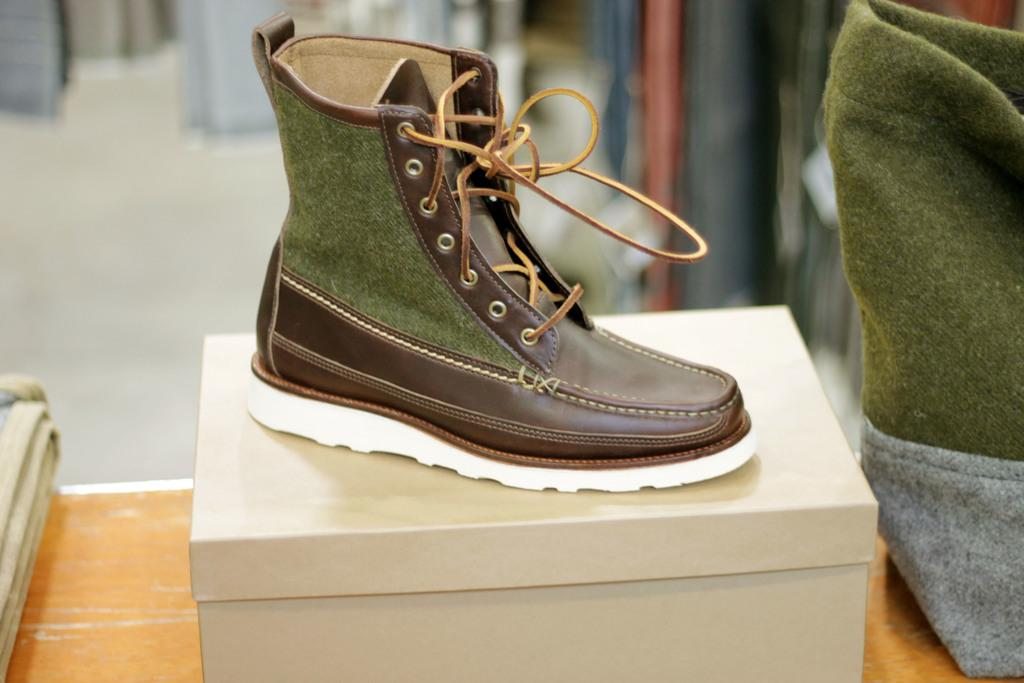What object is placed on a stool in the image? There is a shoe placed on a stool in the image. What is the position of the cloth-like object in the image? The cloth-like object is on the right side of the image. How would you describe the background of the image? The background appears blurry in the image. Can you tell if the stool is placed on a table? The stool may be placed on a table, but it is not explicitly mentioned in the facts. What is the name of the robin that is perched on the shoe in the image? There is no robin present in the image; it only features a shoe placed on a stool. 